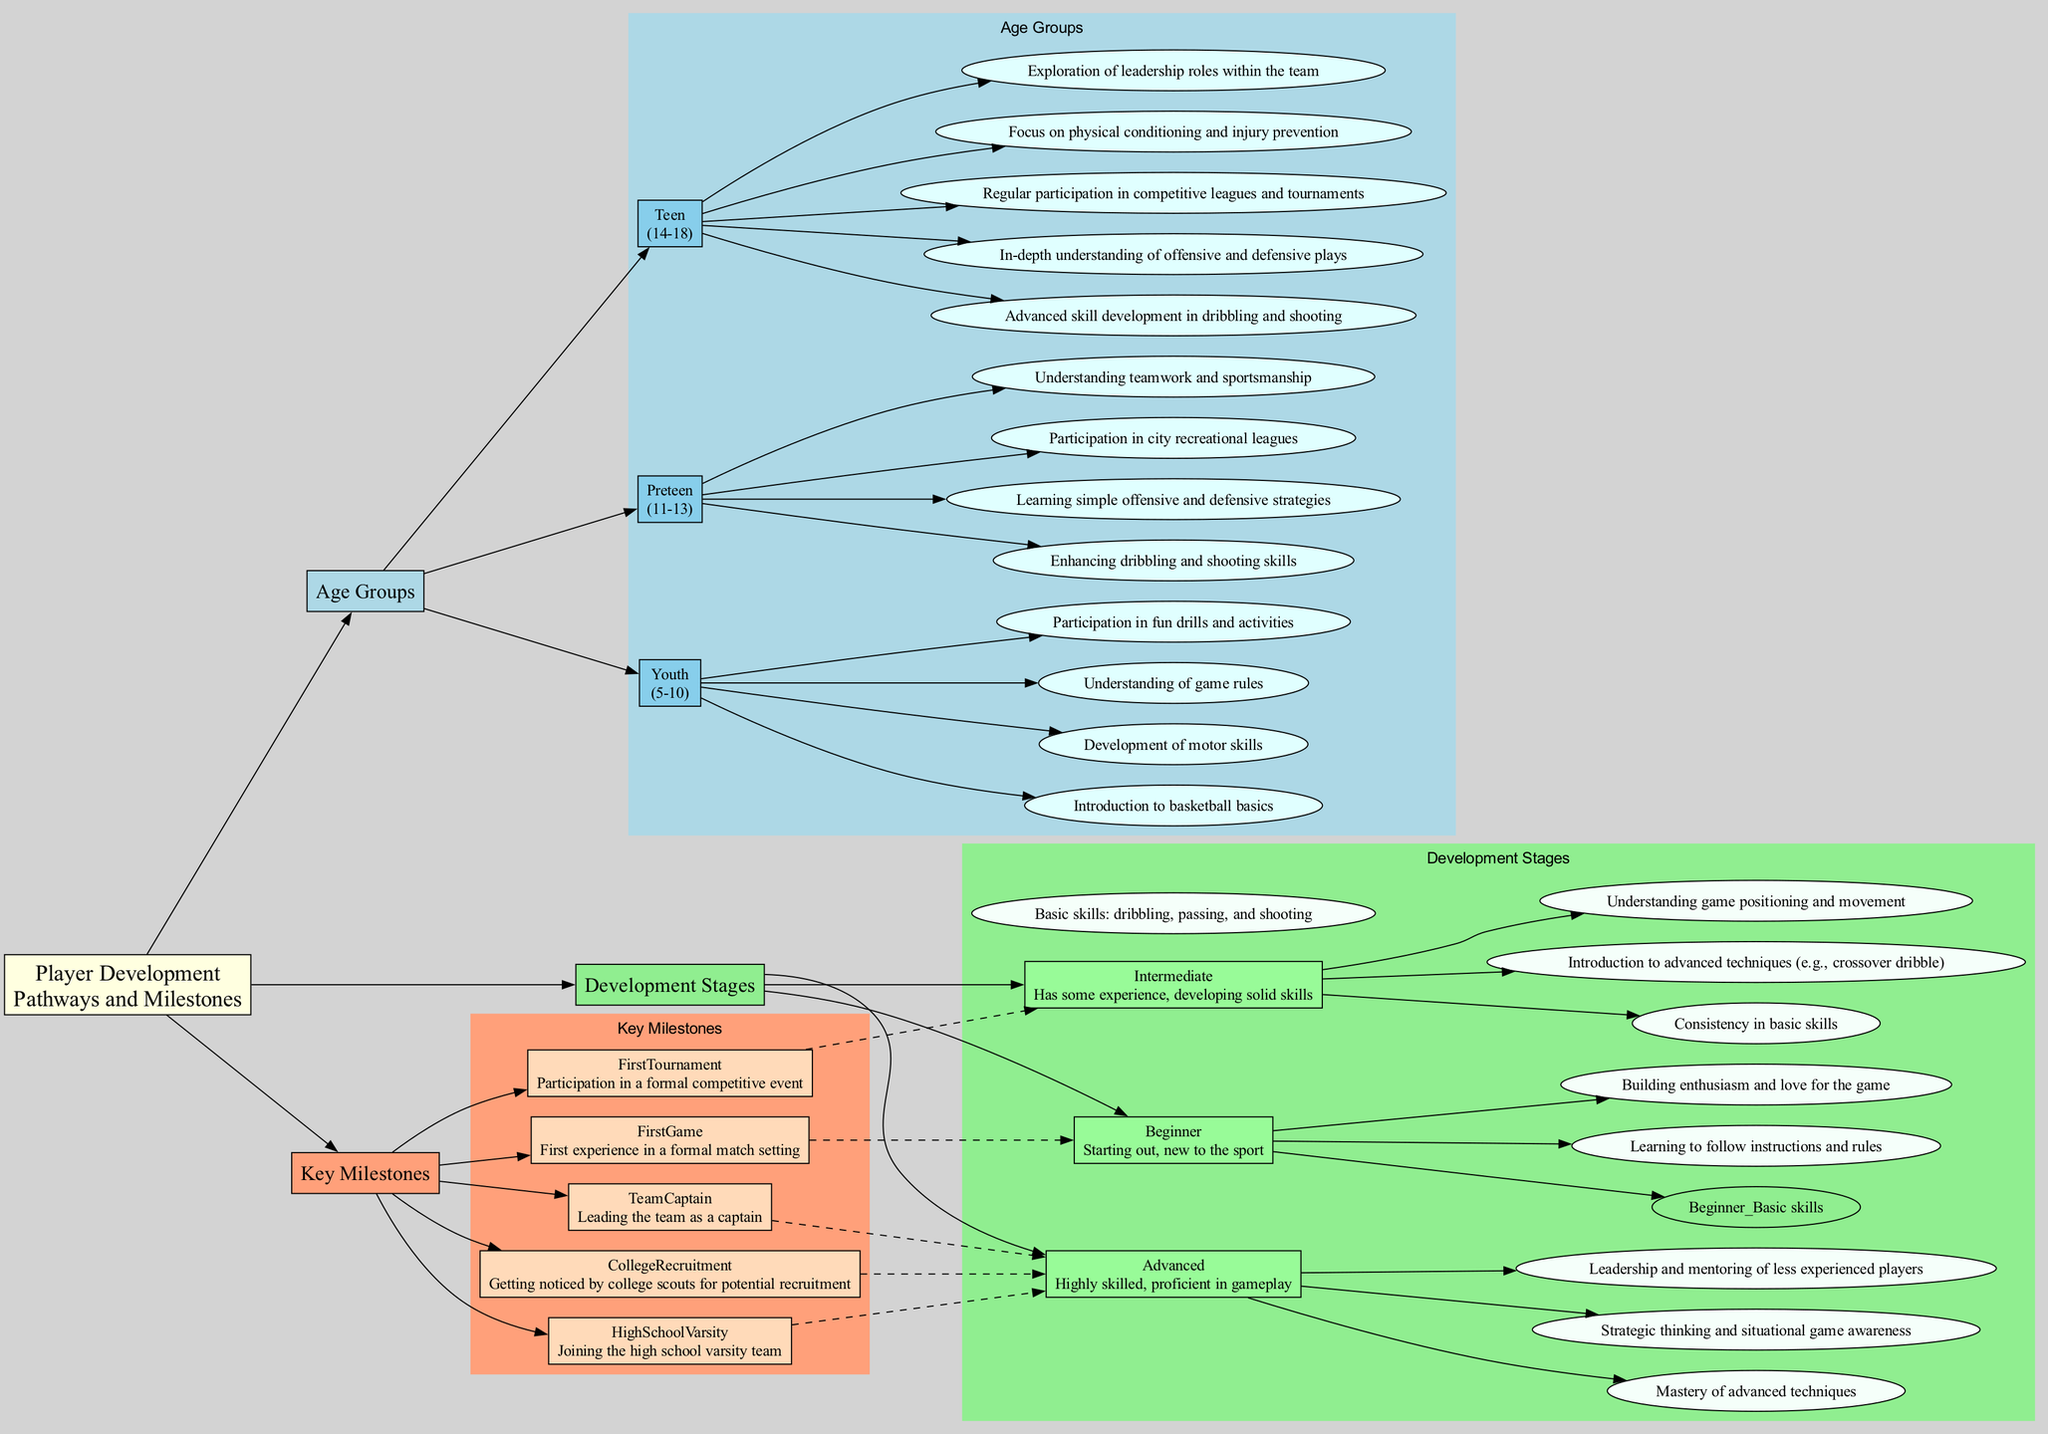What age group is associated with motor skills development? The diagram indicates that motor skills development is a milestone within the "Youth" age group, which covers ages 5-10.
Answer: Youth How many developmental stages are outlined in the diagram? The diagram presents a total of three developmental stages: Beginner, Intermediate, and Advanced.
Answer: 3 Which key milestone is connected to the Intermediate stage? According to the diagram, the key milestone connected to the Intermediate stage is "FirstTournament," which signifies participation in a competitive event.
Answer: FirstTournament What is the focus area for the Advanced developmental stage? The diagram lists "Leadership and mentoring of less experienced players" as one of the focus areas for the Advanced developmental stage.
Answer: Leadership and mentoring of less experienced players Which milestone is associated with joining a high school varsity team? The diagram shows that "HighSchoolVarsity" is the milestone that signifies joining the high school varsity team.
Answer: HighSchoolVarsity What is the relationship between the Youth age group and understanding game rules? The understanding of game rules is a milestone that is specifically positioned under the Youth age group, indicating that it is a focus during that developmental period.
Answer: Understanding of game rules Which developmental stage focuses on mastering advanced techniques? The Advanced stage is dedicated to mastering advanced techniques, showcasing the highest level of skill among players.
Answer: Advanced What milestone represents the first experience in a formal match? The diagram denotes "FirstGame" as the milestone representing a player's first experience in a formal match setting.
Answer: FirstGame 